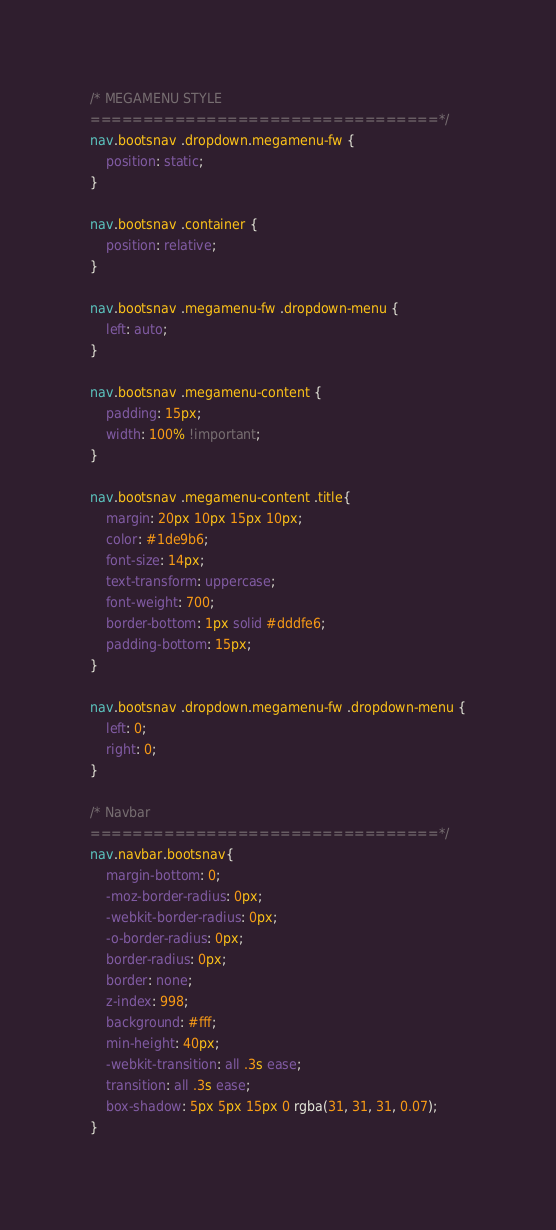<code> <loc_0><loc_0><loc_500><loc_500><_CSS_>/* MEGAMENU STYLE
=================================*/
nav.bootsnav .dropdown.megamenu-fw {
    position: static;
}

nav.bootsnav .container {
    position: relative;
}

nav.bootsnav .megamenu-fw .dropdown-menu {
    left: auto;
}

nav.bootsnav .megamenu-content {
    padding: 15px;
    width: 100% !important;
}

nav.bootsnav .megamenu-content .title{
    margin: 20px 10px 15px 10px;
    color: #1de9b6;
    font-size: 14px;
    text-transform: uppercase;
    font-weight: 700;
    border-bottom: 1px solid #dddfe6;
    padding-bottom: 15px;
}

nav.bootsnav .dropdown.megamenu-fw .dropdown-menu {
    left: 0;
    right: 0;
}

/* Navbar
=================================*/
nav.navbar.bootsnav{
    margin-bottom: 0;
    -moz-border-radius: 0px;
    -webkit-border-radius: 0px;
    -o-border-radius: 0px;
    border-radius: 0px;
    border: none;
    z-index: 998;
	background: #fff;
	min-height: 40px;
	-webkit-transition: all .3s ease;
    transition: all .3s ease;
	box-shadow: 5px 5px 15px 0 rgba(31, 31, 31, 0.07);
}
</code> 